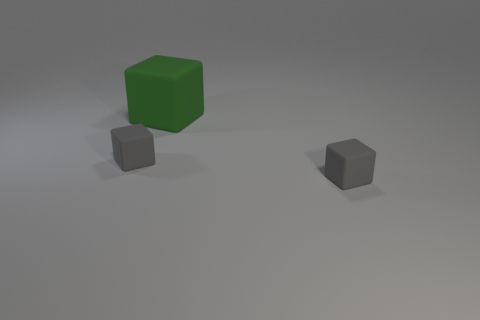Subtract all gray cubes. How many cubes are left? 1 Subtract 1 blocks. How many blocks are left? 2 Add 2 rubber blocks. How many objects exist? 5 Subtract all tiny matte cubes. How many cubes are left? 1 Subtract 0 cyan balls. How many objects are left? 3 Subtract all gray blocks. Subtract all red balls. How many blocks are left? 1 Subtract all gray cylinders. How many yellow cubes are left? 0 Subtract all green things. Subtract all rubber balls. How many objects are left? 2 Add 1 big green objects. How many big green objects are left? 2 Add 1 small purple objects. How many small purple objects exist? 1 